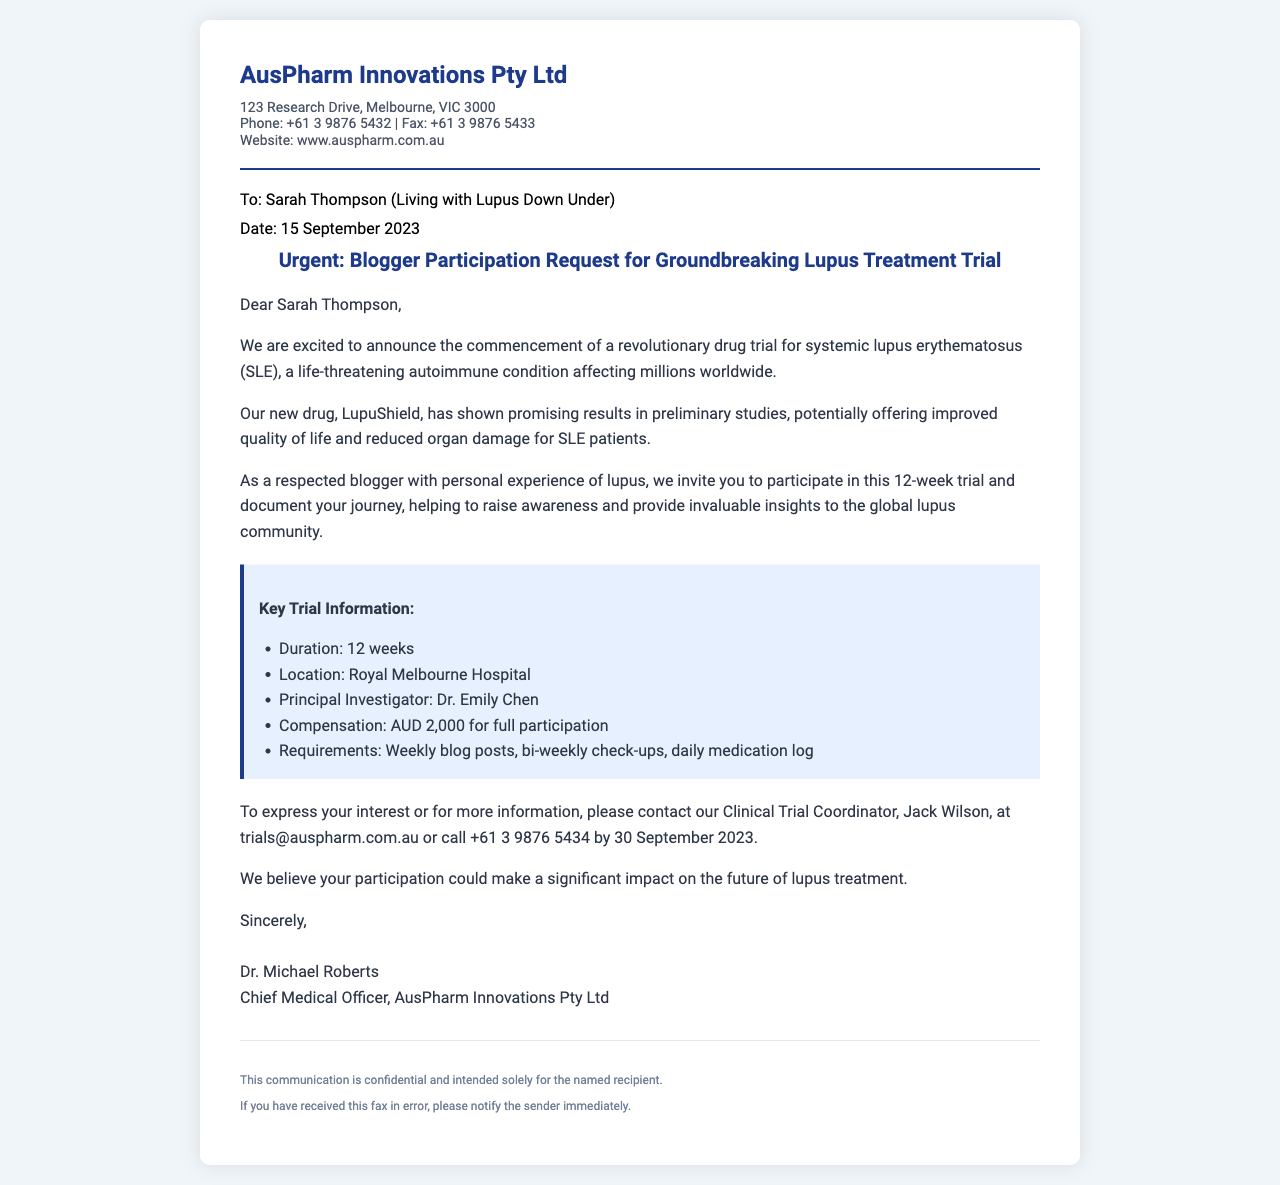What is the name of the new drug being trialed? The new drug mentioned in the document is identified as LupuShield.
Answer: LupuShield Who is the Principal Investigator for the trial? The document states that the Principal Investigator is Dr. Emily Chen.
Answer: Dr. Emily Chen What is the compensation for full participation in the trial? The fax details that the compensation for full participation is AUD 2,000.
Answer: AUD 2,000 What is the duration of the drug trial? The document specifies that the duration of the trial is 12 weeks.
Answer: 12 weeks By what date should interested participants contact the Clinical Trial Coordinator? The document indicates that interested participants should contact by 30 September 2023.
Answer: 30 September 2023 Why is Sarah Thompson being invited to participate in the trial? Sarah Thompson is invited due to her status as a respected blogger with personal experience of lupus.
Answer: Respected blogger with personal experience of lupus What are the requirements for participation in the trial? The requirements include weekly blog posts, bi-weekly check-ups, and a daily medication log.
Answer: Weekly blog posts, bi-weekly check-ups, daily medication log What is the location of the trial? The fax states that the trial will take place at the Royal Melbourne Hospital.
Answer: Royal Melbourne Hospital 